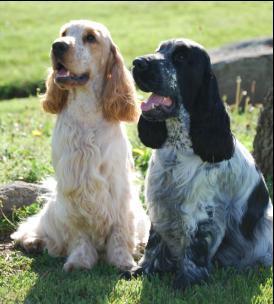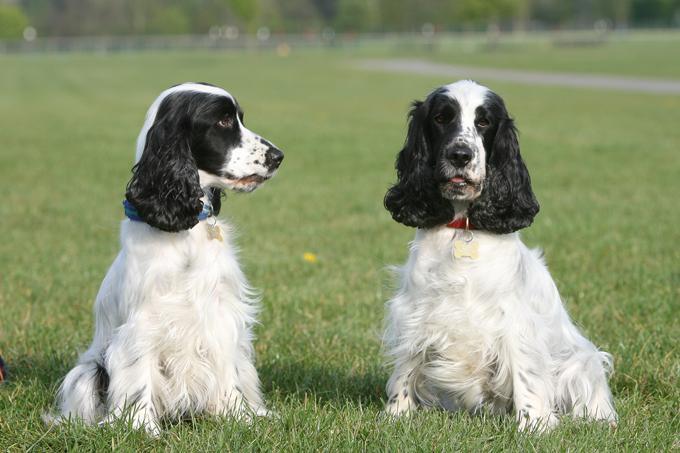The first image is the image on the left, the second image is the image on the right. Examine the images to the left and right. Is the description "The right photo shows a dog standing in the grass." accurate? Answer yes or no. No. The first image is the image on the left, the second image is the image on the right. Assess this claim about the two images: "There are two dogs shown in total". Correct or not? Answer yes or no. No. 